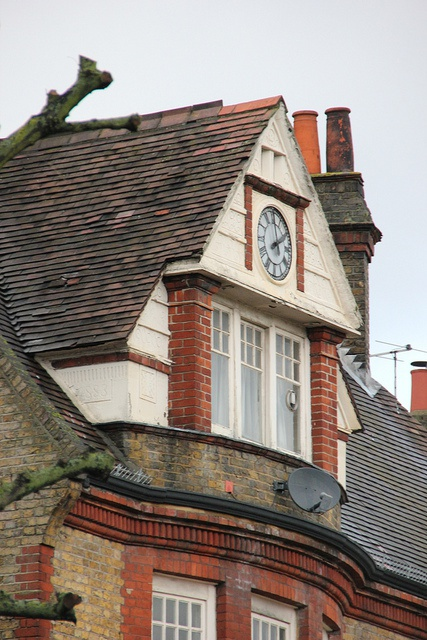Describe the objects in this image and their specific colors. I can see a clock in lightgray, darkgray, and gray tones in this image. 